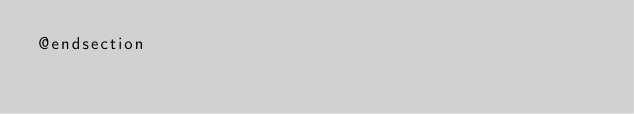Convert code to text. <code><loc_0><loc_0><loc_500><loc_500><_PHP_>@endsection</code> 